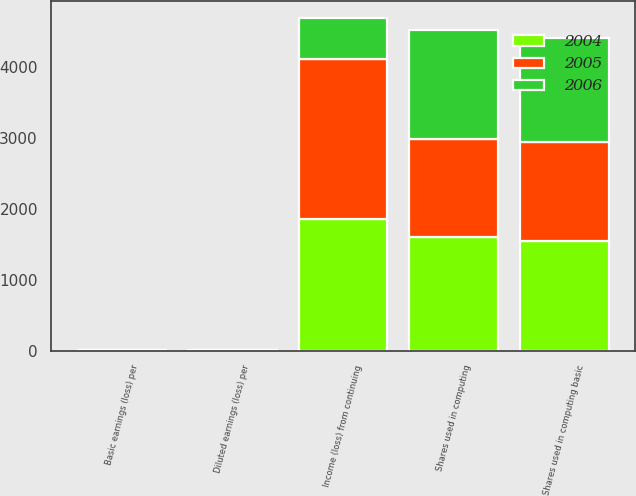Convert chart. <chart><loc_0><loc_0><loc_500><loc_500><stacked_bar_chart><ecel><fcel>Income (loss) from continuing<fcel>Basic earnings (loss) per<fcel>Diluted earnings (loss) per<fcel>Shares used in computing basic<fcel>Shares used in computing<nl><fcel>2004<fcel>1855<fcel>1.2<fcel>1.16<fcel>1550<fcel>1594<nl><fcel>2006<fcel>585<fcel>0.4<fcel>0.38<fcel>1464<fcel>1535<nl><fcel>2005<fcel>2251<fcel>1.62<fcel>1.62<fcel>1386<fcel>1386<nl></chart> 